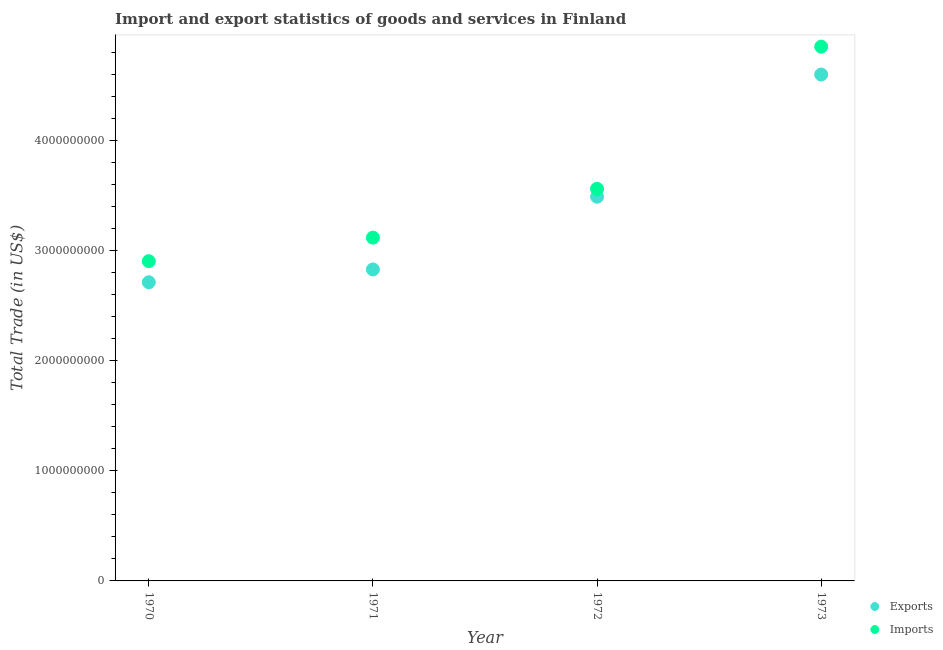How many different coloured dotlines are there?
Offer a very short reply. 2. What is the imports of goods and services in 1970?
Keep it short and to the point. 2.90e+09. Across all years, what is the maximum export of goods and services?
Provide a short and direct response. 4.60e+09. Across all years, what is the minimum export of goods and services?
Keep it short and to the point. 2.71e+09. In which year was the imports of goods and services minimum?
Make the answer very short. 1970. What is the total imports of goods and services in the graph?
Keep it short and to the point. 1.44e+1. What is the difference between the imports of goods and services in 1971 and that in 1973?
Your answer should be compact. -1.73e+09. What is the difference between the export of goods and services in 1970 and the imports of goods and services in 1971?
Provide a short and direct response. -4.05e+08. What is the average imports of goods and services per year?
Your response must be concise. 3.61e+09. In the year 1973, what is the difference between the imports of goods and services and export of goods and services?
Offer a terse response. 2.53e+08. In how many years, is the export of goods and services greater than 400000000 US$?
Ensure brevity in your answer.  4. What is the ratio of the imports of goods and services in 1972 to that in 1973?
Provide a succinct answer. 0.73. Is the export of goods and services in 1970 less than that in 1973?
Make the answer very short. Yes. What is the difference between the highest and the second highest imports of goods and services?
Provide a short and direct response. 1.29e+09. What is the difference between the highest and the lowest imports of goods and services?
Give a very brief answer. 1.95e+09. In how many years, is the imports of goods and services greater than the average imports of goods and services taken over all years?
Offer a very short reply. 1. Is the export of goods and services strictly greater than the imports of goods and services over the years?
Your response must be concise. No. Is the imports of goods and services strictly less than the export of goods and services over the years?
Ensure brevity in your answer.  No. How many dotlines are there?
Your response must be concise. 2. How many years are there in the graph?
Offer a very short reply. 4. Does the graph contain any zero values?
Give a very brief answer. No. Does the graph contain grids?
Provide a succinct answer. No. Where does the legend appear in the graph?
Your answer should be compact. Bottom right. How are the legend labels stacked?
Make the answer very short. Vertical. What is the title of the graph?
Your response must be concise. Import and export statistics of goods and services in Finland. What is the label or title of the Y-axis?
Your response must be concise. Total Trade (in US$). What is the Total Trade (in US$) in Exports in 1970?
Provide a short and direct response. 2.71e+09. What is the Total Trade (in US$) in Imports in 1970?
Provide a succinct answer. 2.90e+09. What is the Total Trade (in US$) of Exports in 1971?
Offer a very short reply. 2.83e+09. What is the Total Trade (in US$) of Imports in 1971?
Your answer should be compact. 3.12e+09. What is the Total Trade (in US$) of Exports in 1972?
Ensure brevity in your answer.  3.49e+09. What is the Total Trade (in US$) in Imports in 1972?
Make the answer very short. 3.56e+09. What is the Total Trade (in US$) in Exports in 1973?
Give a very brief answer. 4.60e+09. What is the Total Trade (in US$) of Imports in 1973?
Offer a terse response. 4.85e+09. Across all years, what is the maximum Total Trade (in US$) in Exports?
Provide a short and direct response. 4.60e+09. Across all years, what is the maximum Total Trade (in US$) in Imports?
Offer a terse response. 4.85e+09. Across all years, what is the minimum Total Trade (in US$) of Exports?
Your response must be concise. 2.71e+09. Across all years, what is the minimum Total Trade (in US$) in Imports?
Provide a succinct answer. 2.90e+09. What is the total Total Trade (in US$) of Exports in the graph?
Offer a terse response. 1.36e+1. What is the total Total Trade (in US$) in Imports in the graph?
Provide a succinct answer. 1.44e+1. What is the difference between the Total Trade (in US$) of Exports in 1970 and that in 1971?
Your answer should be compact. -1.16e+08. What is the difference between the Total Trade (in US$) of Imports in 1970 and that in 1971?
Make the answer very short. -2.14e+08. What is the difference between the Total Trade (in US$) in Exports in 1970 and that in 1972?
Make the answer very short. -7.76e+08. What is the difference between the Total Trade (in US$) of Imports in 1970 and that in 1972?
Your answer should be compact. -6.57e+08. What is the difference between the Total Trade (in US$) in Exports in 1970 and that in 1973?
Make the answer very short. -1.89e+09. What is the difference between the Total Trade (in US$) of Imports in 1970 and that in 1973?
Ensure brevity in your answer.  -1.95e+09. What is the difference between the Total Trade (in US$) of Exports in 1971 and that in 1972?
Provide a succinct answer. -6.60e+08. What is the difference between the Total Trade (in US$) in Imports in 1971 and that in 1972?
Your response must be concise. -4.42e+08. What is the difference between the Total Trade (in US$) of Exports in 1971 and that in 1973?
Provide a short and direct response. -1.77e+09. What is the difference between the Total Trade (in US$) of Imports in 1971 and that in 1973?
Your answer should be compact. -1.73e+09. What is the difference between the Total Trade (in US$) of Exports in 1972 and that in 1973?
Keep it short and to the point. -1.11e+09. What is the difference between the Total Trade (in US$) in Imports in 1972 and that in 1973?
Provide a short and direct response. -1.29e+09. What is the difference between the Total Trade (in US$) of Exports in 1970 and the Total Trade (in US$) of Imports in 1971?
Give a very brief answer. -4.05e+08. What is the difference between the Total Trade (in US$) in Exports in 1970 and the Total Trade (in US$) in Imports in 1972?
Make the answer very short. -8.48e+08. What is the difference between the Total Trade (in US$) of Exports in 1970 and the Total Trade (in US$) of Imports in 1973?
Offer a very short reply. -2.14e+09. What is the difference between the Total Trade (in US$) in Exports in 1971 and the Total Trade (in US$) in Imports in 1972?
Provide a succinct answer. -7.31e+08. What is the difference between the Total Trade (in US$) of Exports in 1971 and the Total Trade (in US$) of Imports in 1973?
Keep it short and to the point. -2.02e+09. What is the difference between the Total Trade (in US$) of Exports in 1972 and the Total Trade (in US$) of Imports in 1973?
Your answer should be compact. -1.36e+09. What is the average Total Trade (in US$) in Exports per year?
Your response must be concise. 3.41e+09. What is the average Total Trade (in US$) in Imports per year?
Your answer should be very brief. 3.61e+09. In the year 1970, what is the difference between the Total Trade (in US$) of Exports and Total Trade (in US$) of Imports?
Ensure brevity in your answer.  -1.91e+08. In the year 1971, what is the difference between the Total Trade (in US$) in Exports and Total Trade (in US$) in Imports?
Provide a succinct answer. -2.89e+08. In the year 1972, what is the difference between the Total Trade (in US$) in Exports and Total Trade (in US$) in Imports?
Give a very brief answer. -7.14e+07. In the year 1973, what is the difference between the Total Trade (in US$) in Exports and Total Trade (in US$) in Imports?
Give a very brief answer. -2.53e+08. What is the ratio of the Total Trade (in US$) of Exports in 1970 to that in 1971?
Offer a very short reply. 0.96. What is the ratio of the Total Trade (in US$) of Imports in 1970 to that in 1971?
Ensure brevity in your answer.  0.93. What is the ratio of the Total Trade (in US$) in Exports in 1970 to that in 1972?
Provide a succinct answer. 0.78. What is the ratio of the Total Trade (in US$) of Imports in 1970 to that in 1972?
Your response must be concise. 0.82. What is the ratio of the Total Trade (in US$) of Exports in 1970 to that in 1973?
Provide a succinct answer. 0.59. What is the ratio of the Total Trade (in US$) of Imports in 1970 to that in 1973?
Your answer should be very brief. 0.6. What is the ratio of the Total Trade (in US$) of Exports in 1971 to that in 1972?
Ensure brevity in your answer.  0.81. What is the ratio of the Total Trade (in US$) in Imports in 1971 to that in 1972?
Keep it short and to the point. 0.88. What is the ratio of the Total Trade (in US$) in Exports in 1971 to that in 1973?
Give a very brief answer. 0.62. What is the ratio of the Total Trade (in US$) in Imports in 1971 to that in 1973?
Give a very brief answer. 0.64. What is the ratio of the Total Trade (in US$) in Exports in 1972 to that in 1973?
Give a very brief answer. 0.76. What is the ratio of the Total Trade (in US$) in Imports in 1972 to that in 1973?
Your answer should be compact. 0.73. What is the difference between the highest and the second highest Total Trade (in US$) of Exports?
Ensure brevity in your answer.  1.11e+09. What is the difference between the highest and the second highest Total Trade (in US$) in Imports?
Your response must be concise. 1.29e+09. What is the difference between the highest and the lowest Total Trade (in US$) of Exports?
Your response must be concise. 1.89e+09. What is the difference between the highest and the lowest Total Trade (in US$) of Imports?
Ensure brevity in your answer.  1.95e+09. 